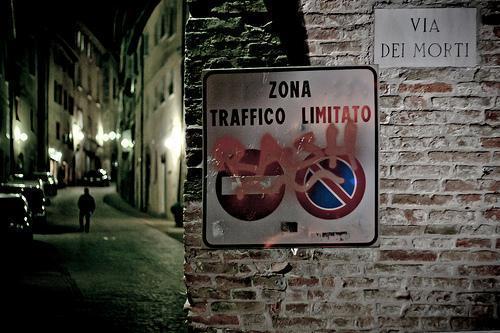How many men are shown?
Give a very brief answer. 1. How many signs are shown?
Give a very brief answer. 2. 